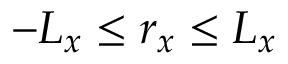Convert formula to latex. <formula><loc_0><loc_0><loc_500><loc_500>- L _ { x } \leq r _ { x } \leq L _ { x }</formula> 